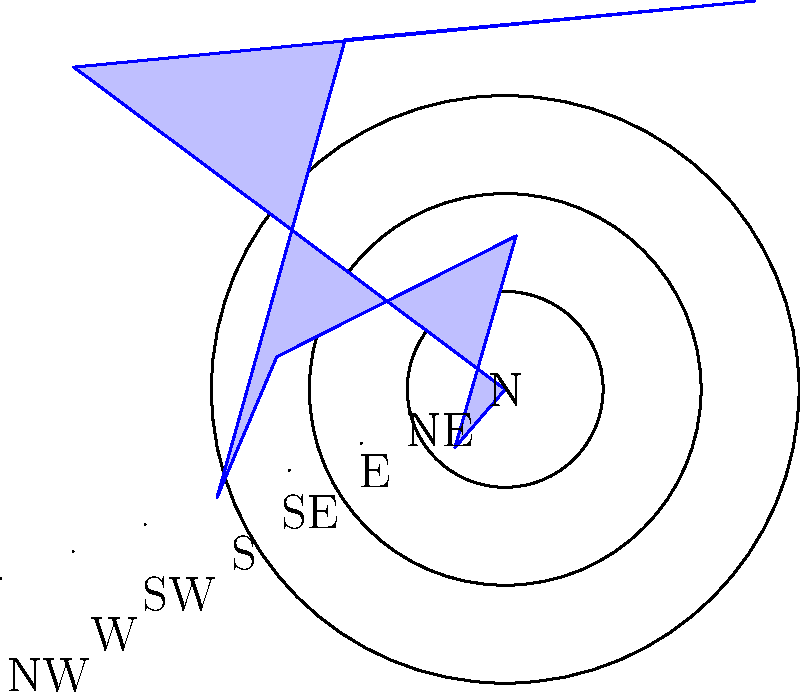The polar rose diagram above represents crime rates in different sectors of a city. Each sector corresponds to a cardinal or intercardinal direction, and the length of each petal indicates the crime rate in that sector. Based on this historical data visualization technique, which sector of the city experiences the highest crime rate, and how does this information relate to traditional law enforcement strategies in urban planning? To answer this question, we need to analyze the polar rose diagram and interpret its implications for law enforcement history:

1. Examine the diagram: The polar rose diagram represents crime rates in eight different sectors of the city, corresponding to cardinal (N, E, S, W) and intercardinal (NE, SE, SW, NW) directions.

2. Identify the longest petal: The longest petal in the diagram represents the highest crime rate. In this case, the longest petal points towards the northeast (NE) direction.

3. Quantify the crime rate: The concentric circles represent crime rate values. The NE petal extends to the second circle, indicating a crime rate of 8 (as each circle represents 2 units).

4. Compare with other sectors: The NE sector has the highest crime rate (8), followed by the South (7), Southeast (6), and North/Northwest (5). The West has the lowest crime rate (2).

5. Historical context: In the history of American law enforcement, such visualizations became popular in the early 20th century as part of the growing emphasis on data-driven policing and urban planning.

6. Strategic implications: This type of data visualization would have informed law enforcement strategies by:
   a) Helping allocate resources more efficiently to high-crime areas.
   b) Guiding urban planning decisions to address environmental factors contributing to crime.
   c) Assisting in the development of targeted crime prevention programs.

7. Evolution of policing: This data-driven approach represents a shift from earlier, more reactive policing methods to a more proactive, analytical approach that became increasingly prevalent in the 20th and 21st centuries.

Therefore, the Northeast sector experiences the highest crime rate, and this type of data visualization has historically been used to inform and shape law enforcement strategies in urban planning and resource allocation.
Answer: Northeast sector; informs resource allocation and crime prevention strategies 